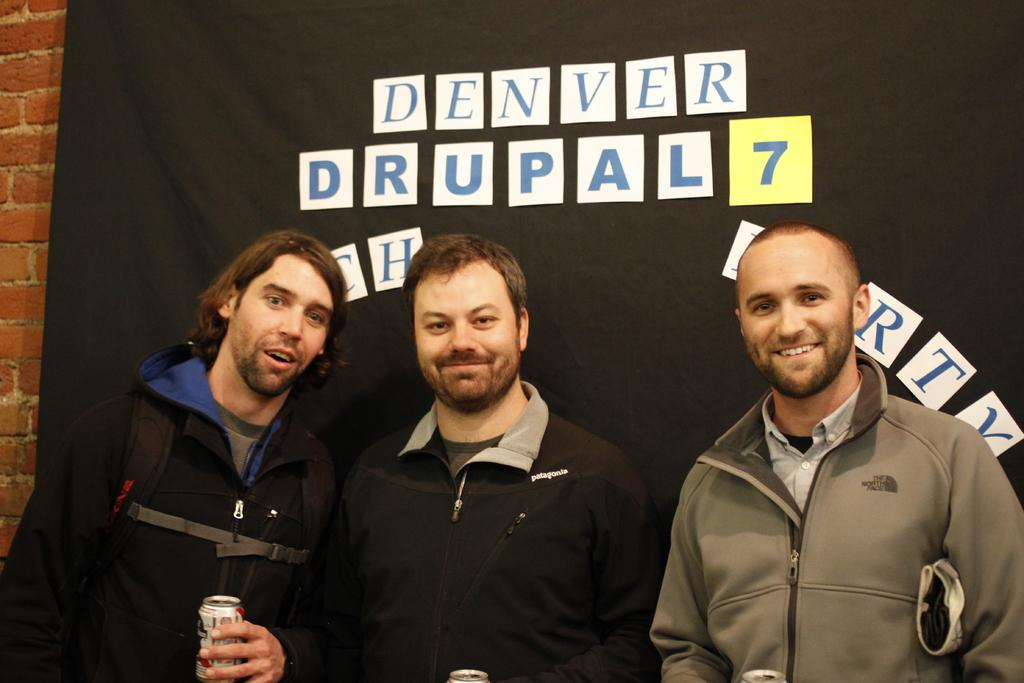<image>
Summarize the visual content of the image. three guys standing in front of sign for denver drupal 7 